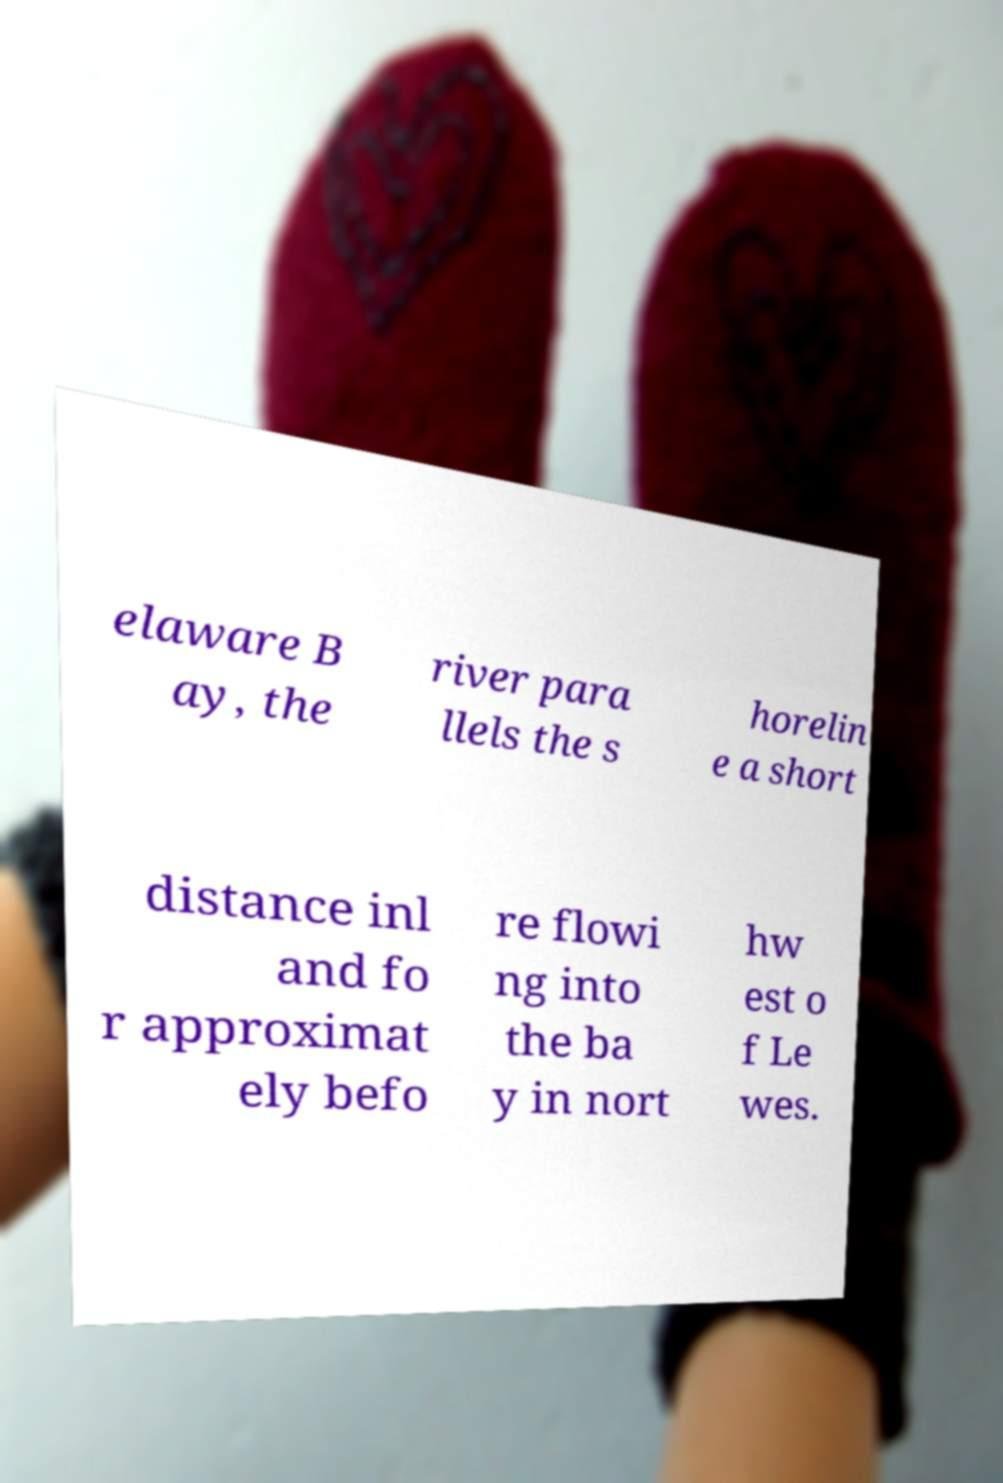What messages or text are displayed in this image? I need them in a readable, typed format. elaware B ay, the river para llels the s horelin e a short distance inl and fo r approximat ely befo re flowi ng into the ba y in nort hw est o f Le wes. 